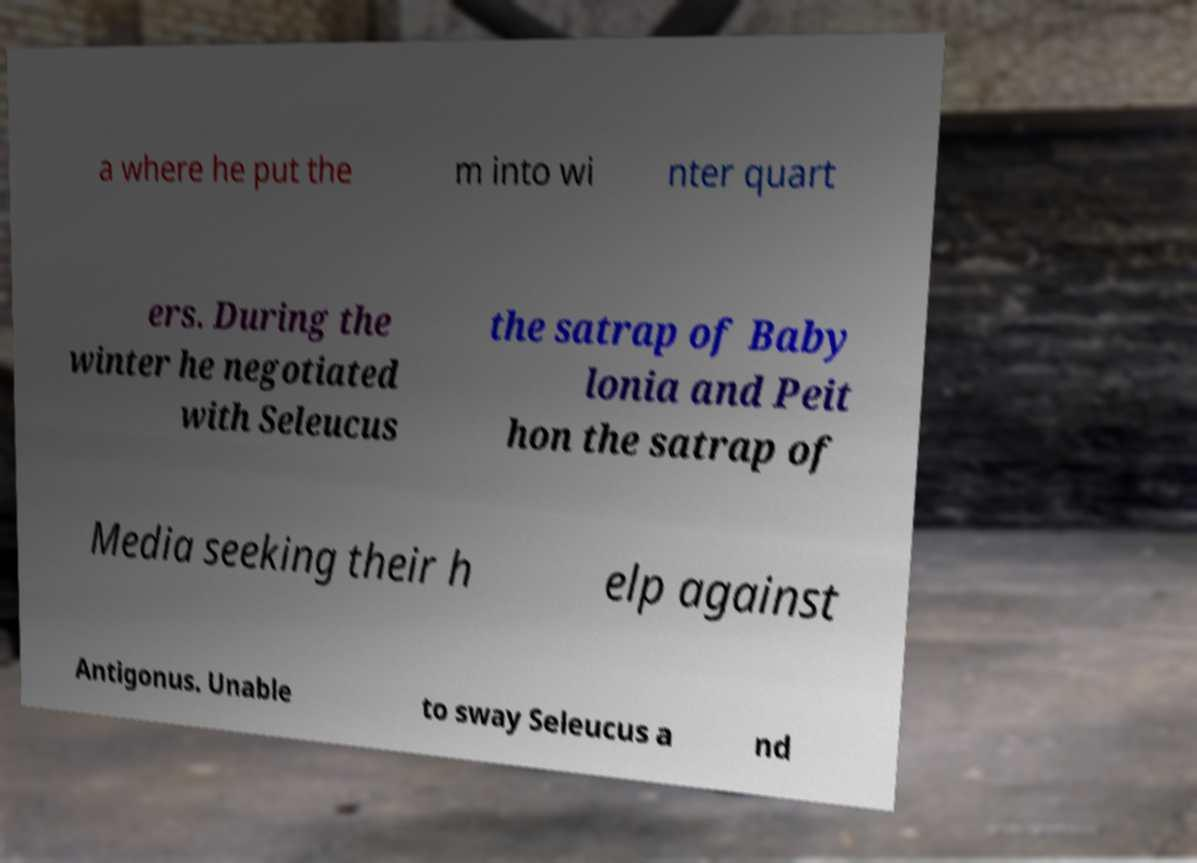What messages or text are displayed in this image? I need them in a readable, typed format. a where he put the m into wi nter quart ers. During the winter he negotiated with Seleucus the satrap of Baby lonia and Peit hon the satrap of Media seeking their h elp against Antigonus. Unable to sway Seleucus a nd 